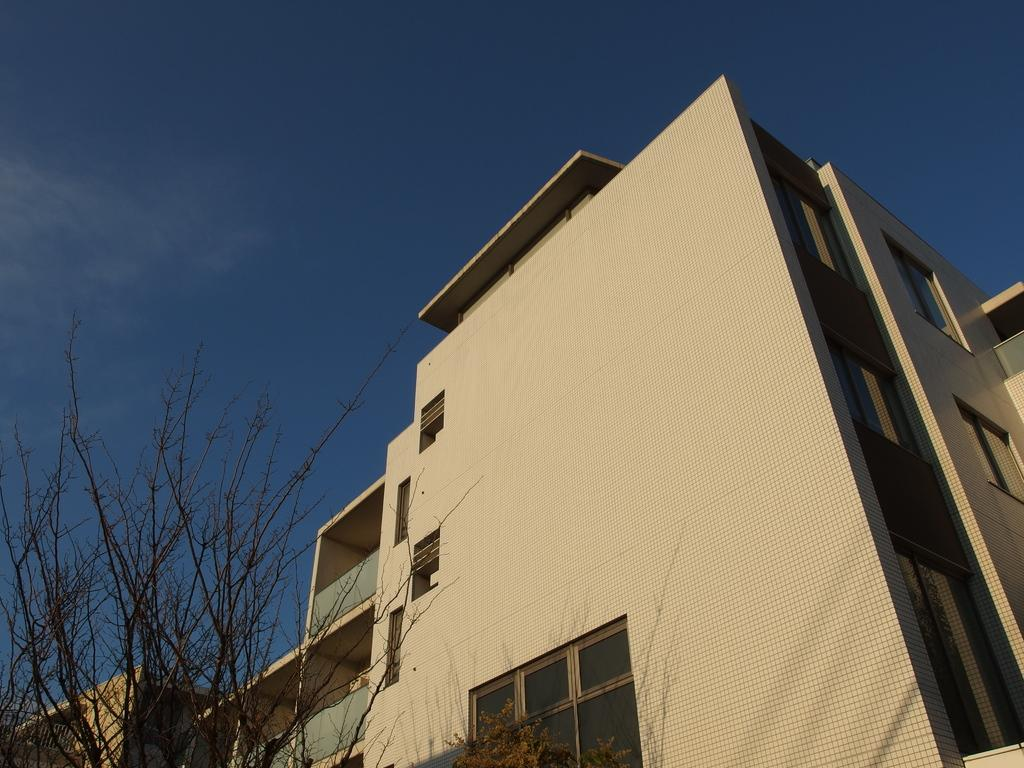What types of structures are located at the bottom of the image? There are buildings at the bottom of the image. What else can be seen at the bottom of the image? There are trees at the bottom of the image. What is visible at the top of the image? The sky is visible at the top of the image. Can you read the letter that is hanging from the locket in the image? There is no letter or locket present in the image. What type of food is being cooked in the image? There is no cooking or food preparation activity depicted in the image. 